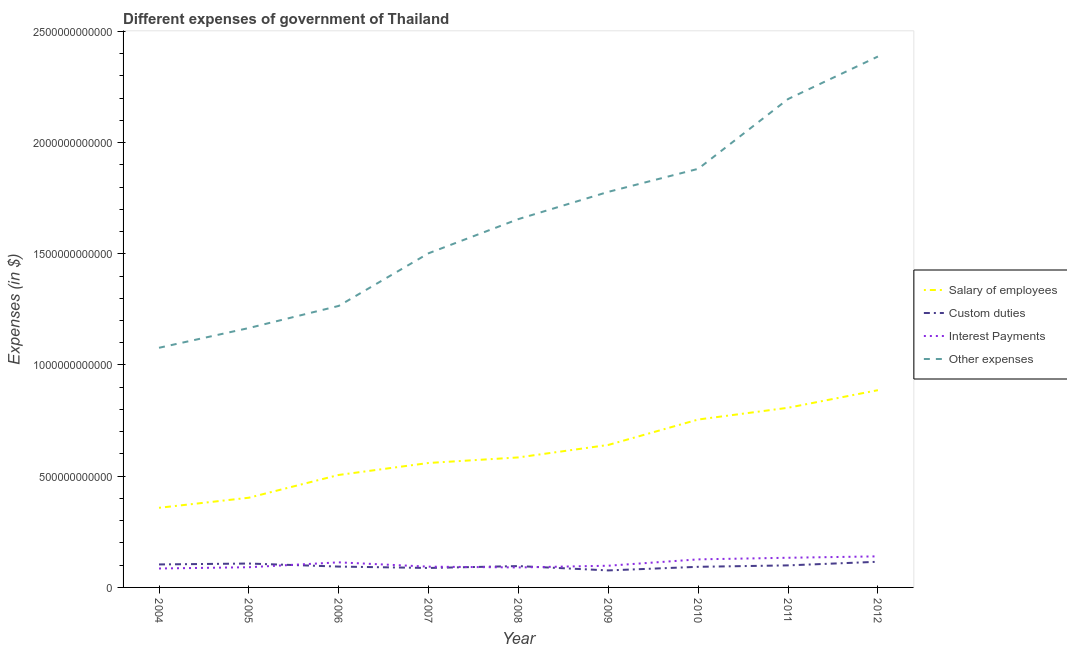How many different coloured lines are there?
Offer a very short reply. 4. Does the line corresponding to amount spent on interest payments intersect with the line corresponding to amount spent on custom duties?
Your answer should be compact. Yes. What is the amount spent on interest payments in 2009?
Offer a very short reply. 9.76e+1. Across all years, what is the maximum amount spent on interest payments?
Your answer should be compact. 1.40e+11. Across all years, what is the minimum amount spent on other expenses?
Ensure brevity in your answer.  1.08e+12. In which year was the amount spent on interest payments maximum?
Your answer should be very brief. 2012. In which year was the amount spent on other expenses minimum?
Give a very brief answer. 2004. What is the total amount spent on other expenses in the graph?
Offer a very short reply. 1.49e+13. What is the difference between the amount spent on custom duties in 2004 and that in 2007?
Give a very brief answer. 1.59e+1. What is the difference between the amount spent on custom duties in 2004 and the amount spent on interest payments in 2012?
Provide a short and direct response. -3.64e+1. What is the average amount spent on interest payments per year?
Your response must be concise. 1.08e+11. In the year 2005, what is the difference between the amount spent on salary of employees and amount spent on other expenses?
Provide a short and direct response. -7.63e+11. What is the ratio of the amount spent on salary of employees in 2010 to that in 2012?
Provide a short and direct response. 0.85. Is the amount spent on salary of employees in 2010 less than that in 2011?
Your answer should be very brief. Yes. Is the difference between the amount spent on other expenses in 2006 and 2010 greater than the difference between the amount spent on interest payments in 2006 and 2010?
Your answer should be very brief. No. What is the difference between the highest and the second highest amount spent on other expenses?
Ensure brevity in your answer.  1.91e+11. What is the difference between the highest and the lowest amount spent on salary of employees?
Ensure brevity in your answer.  5.29e+11. In how many years, is the amount spent on custom duties greater than the average amount spent on custom duties taken over all years?
Make the answer very short. 4. Is the sum of the amount spent on custom duties in 2006 and 2007 greater than the maximum amount spent on salary of employees across all years?
Provide a short and direct response. No. Is it the case that in every year, the sum of the amount spent on interest payments and amount spent on salary of employees is greater than the sum of amount spent on custom duties and amount spent on other expenses?
Provide a short and direct response. Yes. Is it the case that in every year, the sum of the amount spent on salary of employees and amount spent on custom duties is greater than the amount spent on interest payments?
Your answer should be compact. Yes. How many years are there in the graph?
Your answer should be very brief. 9. What is the difference between two consecutive major ticks on the Y-axis?
Give a very brief answer. 5.00e+11. Are the values on the major ticks of Y-axis written in scientific E-notation?
Make the answer very short. No. How many legend labels are there?
Offer a terse response. 4. What is the title of the graph?
Provide a short and direct response. Different expenses of government of Thailand. What is the label or title of the Y-axis?
Your response must be concise. Expenses (in $). What is the Expenses (in $) of Salary of employees in 2004?
Your response must be concise. 3.58e+11. What is the Expenses (in $) in Custom duties in 2004?
Provide a short and direct response. 1.03e+11. What is the Expenses (in $) of Interest Payments in 2004?
Keep it short and to the point. 8.51e+1. What is the Expenses (in $) in Other expenses in 2004?
Provide a short and direct response. 1.08e+12. What is the Expenses (in $) in Salary of employees in 2005?
Provide a succinct answer. 4.03e+11. What is the Expenses (in $) in Custom duties in 2005?
Your response must be concise. 1.07e+11. What is the Expenses (in $) in Interest Payments in 2005?
Ensure brevity in your answer.  9.08e+1. What is the Expenses (in $) of Other expenses in 2005?
Keep it short and to the point. 1.17e+12. What is the Expenses (in $) in Salary of employees in 2006?
Offer a very short reply. 5.06e+11. What is the Expenses (in $) of Custom duties in 2006?
Ensure brevity in your answer.  9.37e+1. What is the Expenses (in $) in Interest Payments in 2006?
Offer a very short reply. 1.13e+11. What is the Expenses (in $) of Other expenses in 2006?
Ensure brevity in your answer.  1.27e+12. What is the Expenses (in $) of Salary of employees in 2007?
Your answer should be compact. 5.59e+11. What is the Expenses (in $) in Custom duties in 2007?
Provide a succinct answer. 8.74e+1. What is the Expenses (in $) of Interest Payments in 2007?
Provide a succinct answer. 9.33e+1. What is the Expenses (in $) in Other expenses in 2007?
Your answer should be compact. 1.50e+12. What is the Expenses (in $) of Salary of employees in 2008?
Make the answer very short. 5.84e+11. What is the Expenses (in $) in Custom duties in 2008?
Make the answer very short. 9.60e+1. What is the Expenses (in $) of Interest Payments in 2008?
Offer a terse response. 8.98e+1. What is the Expenses (in $) in Other expenses in 2008?
Make the answer very short. 1.66e+12. What is the Expenses (in $) of Salary of employees in 2009?
Give a very brief answer. 6.41e+11. What is the Expenses (in $) in Custom duties in 2009?
Your answer should be compact. 7.65e+1. What is the Expenses (in $) in Interest Payments in 2009?
Your response must be concise. 9.76e+1. What is the Expenses (in $) of Other expenses in 2009?
Keep it short and to the point. 1.78e+12. What is the Expenses (in $) of Salary of employees in 2010?
Offer a terse response. 7.55e+11. What is the Expenses (in $) in Custom duties in 2010?
Provide a succinct answer. 9.27e+1. What is the Expenses (in $) in Interest Payments in 2010?
Provide a short and direct response. 1.26e+11. What is the Expenses (in $) of Other expenses in 2010?
Provide a short and direct response. 1.88e+12. What is the Expenses (in $) of Salary of employees in 2011?
Your answer should be compact. 8.08e+11. What is the Expenses (in $) of Custom duties in 2011?
Make the answer very short. 9.91e+1. What is the Expenses (in $) of Interest Payments in 2011?
Offer a very short reply. 1.33e+11. What is the Expenses (in $) in Other expenses in 2011?
Offer a very short reply. 2.20e+12. What is the Expenses (in $) in Salary of employees in 2012?
Your answer should be very brief. 8.87e+11. What is the Expenses (in $) in Custom duties in 2012?
Offer a terse response. 1.15e+11. What is the Expenses (in $) in Interest Payments in 2012?
Offer a terse response. 1.40e+11. What is the Expenses (in $) of Other expenses in 2012?
Offer a terse response. 2.39e+12. Across all years, what is the maximum Expenses (in $) in Salary of employees?
Offer a terse response. 8.87e+11. Across all years, what is the maximum Expenses (in $) of Custom duties?
Offer a terse response. 1.15e+11. Across all years, what is the maximum Expenses (in $) in Interest Payments?
Provide a short and direct response. 1.40e+11. Across all years, what is the maximum Expenses (in $) in Other expenses?
Offer a very short reply. 2.39e+12. Across all years, what is the minimum Expenses (in $) in Salary of employees?
Keep it short and to the point. 3.58e+11. Across all years, what is the minimum Expenses (in $) of Custom duties?
Your answer should be very brief. 7.65e+1. Across all years, what is the minimum Expenses (in $) in Interest Payments?
Keep it short and to the point. 8.51e+1. Across all years, what is the minimum Expenses (in $) in Other expenses?
Offer a very short reply. 1.08e+12. What is the total Expenses (in $) in Salary of employees in the graph?
Make the answer very short. 5.50e+12. What is the total Expenses (in $) in Custom duties in the graph?
Keep it short and to the point. 8.72e+11. What is the total Expenses (in $) in Interest Payments in the graph?
Give a very brief answer. 9.69e+11. What is the total Expenses (in $) in Other expenses in the graph?
Make the answer very short. 1.49e+13. What is the difference between the Expenses (in $) of Salary of employees in 2004 and that in 2005?
Provide a succinct answer. -4.53e+1. What is the difference between the Expenses (in $) in Custom duties in 2004 and that in 2005?
Your answer should be compact. -4.06e+09. What is the difference between the Expenses (in $) of Interest Payments in 2004 and that in 2005?
Your answer should be compact. -5.71e+09. What is the difference between the Expenses (in $) in Other expenses in 2004 and that in 2005?
Your response must be concise. -8.88e+1. What is the difference between the Expenses (in $) of Salary of employees in 2004 and that in 2006?
Provide a short and direct response. -1.48e+11. What is the difference between the Expenses (in $) in Custom duties in 2004 and that in 2006?
Ensure brevity in your answer.  9.59e+09. What is the difference between the Expenses (in $) in Interest Payments in 2004 and that in 2006?
Your response must be concise. -2.77e+1. What is the difference between the Expenses (in $) of Other expenses in 2004 and that in 2006?
Make the answer very short. -1.88e+11. What is the difference between the Expenses (in $) of Salary of employees in 2004 and that in 2007?
Give a very brief answer. -2.02e+11. What is the difference between the Expenses (in $) of Custom duties in 2004 and that in 2007?
Offer a terse response. 1.59e+1. What is the difference between the Expenses (in $) in Interest Payments in 2004 and that in 2007?
Provide a short and direct response. -8.24e+09. What is the difference between the Expenses (in $) in Other expenses in 2004 and that in 2007?
Make the answer very short. -4.25e+11. What is the difference between the Expenses (in $) of Salary of employees in 2004 and that in 2008?
Give a very brief answer. -2.27e+11. What is the difference between the Expenses (in $) of Custom duties in 2004 and that in 2008?
Give a very brief answer. 7.33e+09. What is the difference between the Expenses (in $) of Interest Payments in 2004 and that in 2008?
Keep it short and to the point. -4.69e+09. What is the difference between the Expenses (in $) of Other expenses in 2004 and that in 2008?
Your answer should be very brief. -5.79e+11. What is the difference between the Expenses (in $) of Salary of employees in 2004 and that in 2009?
Make the answer very short. -2.83e+11. What is the difference between the Expenses (in $) of Custom duties in 2004 and that in 2009?
Provide a short and direct response. 2.69e+1. What is the difference between the Expenses (in $) in Interest Payments in 2004 and that in 2009?
Give a very brief answer. -1.24e+1. What is the difference between the Expenses (in $) in Other expenses in 2004 and that in 2009?
Offer a terse response. -7.01e+11. What is the difference between the Expenses (in $) in Salary of employees in 2004 and that in 2010?
Offer a very short reply. -3.97e+11. What is the difference between the Expenses (in $) of Custom duties in 2004 and that in 2010?
Provide a short and direct response. 1.07e+1. What is the difference between the Expenses (in $) of Interest Payments in 2004 and that in 2010?
Your answer should be compact. -4.10e+1. What is the difference between the Expenses (in $) of Other expenses in 2004 and that in 2010?
Make the answer very short. -8.05e+11. What is the difference between the Expenses (in $) of Salary of employees in 2004 and that in 2011?
Provide a succinct answer. -4.50e+11. What is the difference between the Expenses (in $) of Custom duties in 2004 and that in 2011?
Ensure brevity in your answer.  4.22e+09. What is the difference between the Expenses (in $) in Interest Payments in 2004 and that in 2011?
Keep it short and to the point. -4.83e+1. What is the difference between the Expenses (in $) of Other expenses in 2004 and that in 2011?
Keep it short and to the point. -1.12e+12. What is the difference between the Expenses (in $) in Salary of employees in 2004 and that in 2012?
Provide a succinct answer. -5.29e+11. What is the difference between the Expenses (in $) in Custom duties in 2004 and that in 2012?
Offer a terse response. -1.21e+1. What is the difference between the Expenses (in $) in Interest Payments in 2004 and that in 2012?
Your response must be concise. -5.46e+1. What is the difference between the Expenses (in $) in Other expenses in 2004 and that in 2012?
Your answer should be very brief. -1.31e+12. What is the difference between the Expenses (in $) in Salary of employees in 2005 and that in 2006?
Offer a very short reply. -1.02e+11. What is the difference between the Expenses (in $) of Custom duties in 2005 and that in 2006?
Your response must be concise. 1.36e+1. What is the difference between the Expenses (in $) in Interest Payments in 2005 and that in 2006?
Your response must be concise. -2.19e+1. What is the difference between the Expenses (in $) in Other expenses in 2005 and that in 2006?
Your response must be concise. -9.94e+1. What is the difference between the Expenses (in $) in Salary of employees in 2005 and that in 2007?
Make the answer very short. -1.56e+11. What is the difference between the Expenses (in $) of Custom duties in 2005 and that in 2007?
Your answer should be very brief. 2.00e+1. What is the difference between the Expenses (in $) in Interest Payments in 2005 and that in 2007?
Keep it short and to the point. -2.53e+09. What is the difference between the Expenses (in $) in Other expenses in 2005 and that in 2007?
Offer a terse response. -3.36e+11. What is the difference between the Expenses (in $) of Salary of employees in 2005 and that in 2008?
Give a very brief answer. -1.81e+11. What is the difference between the Expenses (in $) in Custom duties in 2005 and that in 2008?
Make the answer very short. 1.14e+1. What is the difference between the Expenses (in $) in Interest Payments in 2005 and that in 2008?
Offer a very short reply. 1.02e+09. What is the difference between the Expenses (in $) in Other expenses in 2005 and that in 2008?
Ensure brevity in your answer.  -4.90e+11. What is the difference between the Expenses (in $) of Salary of employees in 2005 and that in 2009?
Make the answer very short. -2.37e+11. What is the difference between the Expenses (in $) of Custom duties in 2005 and that in 2009?
Provide a succinct answer. 3.09e+1. What is the difference between the Expenses (in $) of Interest Payments in 2005 and that in 2009?
Offer a terse response. -6.73e+09. What is the difference between the Expenses (in $) in Other expenses in 2005 and that in 2009?
Your response must be concise. -6.12e+11. What is the difference between the Expenses (in $) in Salary of employees in 2005 and that in 2010?
Your answer should be very brief. -3.52e+11. What is the difference between the Expenses (in $) in Custom duties in 2005 and that in 2010?
Ensure brevity in your answer.  1.47e+1. What is the difference between the Expenses (in $) in Interest Payments in 2005 and that in 2010?
Provide a succinct answer. -3.53e+1. What is the difference between the Expenses (in $) in Other expenses in 2005 and that in 2010?
Make the answer very short. -7.16e+11. What is the difference between the Expenses (in $) in Salary of employees in 2005 and that in 2011?
Your answer should be compact. -4.04e+11. What is the difference between the Expenses (in $) of Custom duties in 2005 and that in 2011?
Give a very brief answer. 8.28e+09. What is the difference between the Expenses (in $) in Interest Payments in 2005 and that in 2011?
Your answer should be very brief. -4.26e+1. What is the difference between the Expenses (in $) in Other expenses in 2005 and that in 2011?
Give a very brief answer. -1.03e+12. What is the difference between the Expenses (in $) of Salary of employees in 2005 and that in 2012?
Your answer should be very brief. -4.83e+11. What is the difference between the Expenses (in $) of Custom duties in 2005 and that in 2012?
Give a very brief answer. -8.00e+09. What is the difference between the Expenses (in $) of Interest Payments in 2005 and that in 2012?
Your response must be concise. -4.89e+1. What is the difference between the Expenses (in $) in Other expenses in 2005 and that in 2012?
Your answer should be compact. -1.22e+12. What is the difference between the Expenses (in $) in Salary of employees in 2006 and that in 2007?
Your response must be concise. -5.38e+1. What is the difference between the Expenses (in $) of Custom duties in 2006 and that in 2007?
Keep it short and to the point. 6.31e+09. What is the difference between the Expenses (in $) in Interest Payments in 2006 and that in 2007?
Provide a short and direct response. 1.94e+1. What is the difference between the Expenses (in $) in Other expenses in 2006 and that in 2007?
Your response must be concise. -2.37e+11. What is the difference between the Expenses (in $) in Salary of employees in 2006 and that in 2008?
Offer a very short reply. -7.89e+1. What is the difference between the Expenses (in $) of Custom duties in 2006 and that in 2008?
Offer a very short reply. -2.25e+09. What is the difference between the Expenses (in $) in Interest Payments in 2006 and that in 2008?
Give a very brief answer. 2.30e+1. What is the difference between the Expenses (in $) in Other expenses in 2006 and that in 2008?
Provide a succinct answer. -3.90e+11. What is the difference between the Expenses (in $) in Salary of employees in 2006 and that in 2009?
Provide a short and direct response. -1.35e+11. What is the difference between the Expenses (in $) of Custom duties in 2006 and that in 2009?
Keep it short and to the point. 1.73e+1. What is the difference between the Expenses (in $) of Interest Payments in 2006 and that in 2009?
Ensure brevity in your answer.  1.52e+1. What is the difference between the Expenses (in $) in Other expenses in 2006 and that in 2009?
Ensure brevity in your answer.  -5.13e+11. What is the difference between the Expenses (in $) in Salary of employees in 2006 and that in 2010?
Ensure brevity in your answer.  -2.49e+11. What is the difference between the Expenses (in $) in Custom duties in 2006 and that in 2010?
Ensure brevity in your answer.  1.07e+09. What is the difference between the Expenses (in $) of Interest Payments in 2006 and that in 2010?
Offer a terse response. -1.34e+1. What is the difference between the Expenses (in $) of Other expenses in 2006 and that in 2010?
Provide a succinct answer. -6.16e+11. What is the difference between the Expenses (in $) of Salary of employees in 2006 and that in 2011?
Your answer should be compact. -3.02e+11. What is the difference between the Expenses (in $) in Custom duties in 2006 and that in 2011?
Give a very brief answer. -5.36e+09. What is the difference between the Expenses (in $) of Interest Payments in 2006 and that in 2011?
Provide a short and direct response. -2.06e+1. What is the difference between the Expenses (in $) in Other expenses in 2006 and that in 2011?
Give a very brief answer. -9.30e+11. What is the difference between the Expenses (in $) of Salary of employees in 2006 and that in 2012?
Offer a very short reply. -3.81e+11. What is the difference between the Expenses (in $) in Custom duties in 2006 and that in 2012?
Your answer should be compact. -2.16e+1. What is the difference between the Expenses (in $) in Interest Payments in 2006 and that in 2012?
Ensure brevity in your answer.  -2.70e+1. What is the difference between the Expenses (in $) of Other expenses in 2006 and that in 2012?
Provide a succinct answer. -1.12e+12. What is the difference between the Expenses (in $) in Salary of employees in 2007 and that in 2008?
Offer a terse response. -2.50e+1. What is the difference between the Expenses (in $) in Custom duties in 2007 and that in 2008?
Provide a succinct answer. -8.56e+09. What is the difference between the Expenses (in $) in Interest Payments in 2007 and that in 2008?
Your answer should be very brief. 3.55e+09. What is the difference between the Expenses (in $) of Other expenses in 2007 and that in 2008?
Keep it short and to the point. -1.54e+11. What is the difference between the Expenses (in $) in Salary of employees in 2007 and that in 2009?
Provide a succinct answer. -8.11e+1. What is the difference between the Expenses (in $) of Custom duties in 2007 and that in 2009?
Offer a very short reply. 1.10e+1. What is the difference between the Expenses (in $) in Interest Payments in 2007 and that in 2009?
Give a very brief answer. -4.21e+09. What is the difference between the Expenses (in $) in Other expenses in 2007 and that in 2009?
Keep it short and to the point. -2.76e+11. What is the difference between the Expenses (in $) in Salary of employees in 2007 and that in 2010?
Offer a terse response. -1.95e+11. What is the difference between the Expenses (in $) of Custom duties in 2007 and that in 2010?
Your response must be concise. -5.23e+09. What is the difference between the Expenses (in $) in Interest Payments in 2007 and that in 2010?
Offer a very short reply. -3.28e+1. What is the difference between the Expenses (in $) in Other expenses in 2007 and that in 2010?
Offer a very short reply. -3.80e+11. What is the difference between the Expenses (in $) in Salary of employees in 2007 and that in 2011?
Your answer should be very brief. -2.48e+11. What is the difference between the Expenses (in $) in Custom duties in 2007 and that in 2011?
Your response must be concise. -1.17e+1. What is the difference between the Expenses (in $) in Interest Payments in 2007 and that in 2011?
Your answer should be compact. -4.00e+1. What is the difference between the Expenses (in $) of Other expenses in 2007 and that in 2011?
Your response must be concise. -6.93e+11. What is the difference between the Expenses (in $) of Salary of employees in 2007 and that in 2012?
Provide a succinct answer. -3.27e+11. What is the difference between the Expenses (in $) of Custom duties in 2007 and that in 2012?
Keep it short and to the point. -2.79e+1. What is the difference between the Expenses (in $) of Interest Payments in 2007 and that in 2012?
Give a very brief answer. -4.64e+1. What is the difference between the Expenses (in $) in Other expenses in 2007 and that in 2012?
Your answer should be compact. -8.84e+11. What is the difference between the Expenses (in $) of Salary of employees in 2008 and that in 2009?
Offer a terse response. -5.61e+1. What is the difference between the Expenses (in $) in Custom duties in 2008 and that in 2009?
Offer a very short reply. 1.95e+1. What is the difference between the Expenses (in $) in Interest Payments in 2008 and that in 2009?
Keep it short and to the point. -7.75e+09. What is the difference between the Expenses (in $) in Other expenses in 2008 and that in 2009?
Your answer should be very brief. -1.22e+11. What is the difference between the Expenses (in $) in Salary of employees in 2008 and that in 2010?
Give a very brief answer. -1.70e+11. What is the difference between the Expenses (in $) of Custom duties in 2008 and that in 2010?
Give a very brief answer. 3.32e+09. What is the difference between the Expenses (in $) in Interest Payments in 2008 and that in 2010?
Offer a very short reply. -3.64e+1. What is the difference between the Expenses (in $) in Other expenses in 2008 and that in 2010?
Provide a short and direct response. -2.26e+11. What is the difference between the Expenses (in $) of Salary of employees in 2008 and that in 2011?
Provide a succinct answer. -2.23e+11. What is the difference between the Expenses (in $) of Custom duties in 2008 and that in 2011?
Ensure brevity in your answer.  -3.11e+09. What is the difference between the Expenses (in $) of Interest Payments in 2008 and that in 2011?
Offer a terse response. -4.36e+1. What is the difference between the Expenses (in $) of Other expenses in 2008 and that in 2011?
Provide a short and direct response. -5.40e+11. What is the difference between the Expenses (in $) of Salary of employees in 2008 and that in 2012?
Your answer should be compact. -3.02e+11. What is the difference between the Expenses (in $) of Custom duties in 2008 and that in 2012?
Provide a short and direct response. -1.94e+1. What is the difference between the Expenses (in $) of Interest Payments in 2008 and that in 2012?
Ensure brevity in your answer.  -4.99e+1. What is the difference between the Expenses (in $) in Other expenses in 2008 and that in 2012?
Ensure brevity in your answer.  -7.31e+11. What is the difference between the Expenses (in $) in Salary of employees in 2009 and that in 2010?
Make the answer very short. -1.14e+11. What is the difference between the Expenses (in $) in Custom duties in 2009 and that in 2010?
Your response must be concise. -1.62e+1. What is the difference between the Expenses (in $) in Interest Payments in 2009 and that in 2010?
Your answer should be compact. -2.86e+1. What is the difference between the Expenses (in $) of Other expenses in 2009 and that in 2010?
Ensure brevity in your answer.  -1.04e+11. What is the difference between the Expenses (in $) of Salary of employees in 2009 and that in 2011?
Offer a very short reply. -1.67e+11. What is the difference between the Expenses (in $) of Custom duties in 2009 and that in 2011?
Ensure brevity in your answer.  -2.26e+1. What is the difference between the Expenses (in $) of Interest Payments in 2009 and that in 2011?
Keep it short and to the point. -3.58e+1. What is the difference between the Expenses (in $) in Other expenses in 2009 and that in 2011?
Offer a very short reply. -4.17e+11. What is the difference between the Expenses (in $) in Salary of employees in 2009 and that in 2012?
Ensure brevity in your answer.  -2.46e+11. What is the difference between the Expenses (in $) in Custom duties in 2009 and that in 2012?
Provide a succinct answer. -3.89e+1. What is the difference between the Expenses (in $) of Interest Payments in 2009 and that in 2012?
Offer a terse response. -4.22e+1. What is the difference between the Expenses (in $) of Other expenses in 2009 and that in 2012?
Provide a succinct answer. -6.08e+11. What is the difference between the Expenses (in $) of Salary of employees in 2010 and that in 2011?
Your answer should be very brief. -5.29e+1. What is the difference between the Expenses (in $) of Custom duties in 2010 and that in 2011?
Provide a succinct answer. -6.44e+09. What is the difference between the Expenses (in $) of Interest Payments in 2010 and that in 2011?
Your answer should be very brief. -7.23e+09. What is the difference between the Expenses (in $) in Other expenses in 2010 and that in 2011?
Provide a succinct answer. -3.14e+11. What is the difference between the Expenses (in $) in Salary of employees in 2010 and that in 2012?
Your answer should be compact. -1.32e+11. What is the difference between the Expenses (in $) of Custom duties in 2010 and that in 2012?
Your response must be concise. -2.27e+1. What is the difference between the Expenses (in $) of Interest Payments in 2010 and that in 2012?
Your response must be concise. -1.36e+1. What is the difference between the Expenses (in $) in Other expenses in 2010 and that in 2012?
Your answer should be very brief. -5.05e+11. What is the difference between the Expenses (in $) of Salary of employees in 2011 and that in 2012?
Offer a terse response. -7.91e+1. What is the difference between the Expenses (in $) of Custom duties in 2011 and that in 2012?
Your answer should be compact. -1.63e+1. What is the difference between the Expenses (in $) in Interest Payments in 2011 and that in 2012?
Keep it short and to the point. -6.33e+09. What is the difference between the Expenses (in $) in Other expenses in 2011 and that in 2012?
Provide a short and direct response. -1.91e+11. What is the difference between the Expenses (in $) in Salary of employees in 2004 and the Expenses (in $) in Custom duties in 2005?
Keep it short and to the point. 2.51e+11. What is the difference between the Expenses (in $) of Salary of employees in 2004 and the Expenses (in $) of Interest Payments in 2005?
Your response must be concise. 2.67e+11. What is the difference between the Expenses (in $) of Salary of employees in 2004 and the Expenses (in $) of Other expenses in 2005?
Your answer should be very brief. -8.08e+11. What is the difference between the Expenses (in $) in Custom duties in 2004 and the Expenses (in $) in Interest Payments in 2005?
Offer a terse response. 1.25e+1. What is the difference between the Expenses (in $) in Custom duties in 2004 and the Expenses (in $) in Other expenses in 2005?
Offer a very short reply. -1.06e+12. What is the difference between the Expenses (in $) in Interest Payments in 2004 and the Expenses (in $) in Other expenses in 2005?
Make the answer very short. -1.08e+12. What is the difference between the Expenses (in $) of Salary of employees in 2004 and the Expenses (in $) of Custom duties in 2006?
Your response must be concise. 2.64e+11. What is the difference between the Expenses (in $) of Salary of employees in 2004 and the Expenses (in $) of Interest Payments in 2006?
Give a very brief answer. 2.45e+11. What is the difference between the Expenses (in $) of Salary of employees in 2004 and the Expenses (in $) of Other expenses in 2006?
Offer a very short reply. -9.08e+11. What is the difference between the Expenses (in $) of Custom duties in 2004 and the Expenses (in $) of Interest Payments in 2006?
Keep it short and to the point. -9.43e+09. What is the difference between the Expenses (in $) in Custom duties in 2004 and the Expenses (in $) in Other expenses in 2006?
Provide a short and direct response. -1.16e+12. What is the difference between the Expenses (in $) of Interest Payments in 2004 and the Expenses (in $) of Other expenses in 2006?
Offer a terse response. -1.18e+12. What is the difference between the Expenses (in $) in Salary of employees in 2004 and the Expenses (in $) in Custom duties in 2007?
Ensure brevity in your answer.  2.70e+11. What is the difference between the Expenses (in $) in Salary of employees in 2004 and the Expenses (in $) in Interest Payments in 2007?
Give a very brief answer. 2.65e+11. What is the difference between the Expenses (in $) in Salary of employees in 2004 and the Expenses (in $) in Other expenses in 2007?
Your answer should be very brief. -1.14e+12. What is the difference between the Expenses (in $) of Custom duties in 2004 and the Expenses (in $) of Interest Payments in 2007?
Keep it short and to the point. 9.99e+09. What is the difference between the Expenses (in $) in Custom duties in 2004 and the Expenses (in $) in Other expenses in 2007?
Ensure brevity in your answer.  -1.40e+12. What is the difference between the Expenses (in $) of Interest Payments in 2004 and the Expenses (in $) of Other expenses in 2007?
Your answer should be compact. -1.42e+12. What is the difference between the Expenses (in $) of Salary of employees in 2004 and the Expenses (in $) of Custom duties in 2008?
Give a very brief answer. 2.62e+11. What is the difference between the Expenses (in $) in Salary of employees in 2004 and the Expenses (in $) in Interest Payments in 2008?
Give a very brief answer. 2.68e+11. What is the difference between the Expenses (in $) of Salary of employees in 2004 and the Expenses (in $) of Other expenses in 2008?
Provide a succinct answer. -1.30e+12. What is the difference between the Expenses (in $) in Custom duties in 2004 and the Expenses (in $) in Interest Payments in 2008?
Your answer should be very brief. 1.35e+1. What is the difference between the Expenses (in $) in Custom duties in 2004 and the Expenses (in $) in Other expenses in 2008?
Ensure brevity in your answer.  -1.55e+12. What is the difference between the Expenses (in $) of Interest Payments in 2004 and the Expenses (in $) of Other expenses in 2008?
Ensure brevity in your answer.  -1.57e+12. What is the difference between the Expenses (in $) of Salary of employees in 2004 and the Expenses (in $) of Custom duties in 2009?
Provide a short and direct response. 2.81e+11. What is the difference between the Expenses (in $) in Salary of employees in 2004 and the Expenses (in $) in Interest Payments in 2009?
Provide a short and direct response. 2.60e+11. What is the difference between the Expenses (in $) of Salary of employees in 2004 and the Expenses (in $) of Other expenses in 2009?
Make the answer very short. -1.42e+12. What is the difference between the Expenses (in $) in Custom duties in 2004 and the Expenses (in $) in Interest Payments in 2009?
Your answer should be very brief. 5.78e+09. What is the difference between the Expenses (in $) of Custom duties in 2004 and the Expenses (in $) of Other expenses in 2009?
Ensure brevity in your answer.  -1.68e+12. What is the difference between the Expenses (in $) in Interest Payments in 2004 and the Expenses (in $) in Other expenses in 2009?
Provide a succinct answer. -1.69e+12. What is the difference between the Expenses (in $) in Salary of employees in 2004 and the Expenses (in $) in Custom duties in 2010?
Provide a succinct answer. 2.65e+11. What is the difference between the Expenses (in $) of Salary of employees in 2004 and the Expenses (in $) of Interest Payments in 2010?
Give a very brief answer. 2.32e+11. What is the difference between the Expenses (in $) in Salary of employees in 2004 and the Expenses (in $) in Other expenses in 2010?
Provide a short and direct response. -1.52e+12. What is the difference between the Expenses (in $) in Custom duties in 2004 and the Expenses (in $) in Interest Payments in 2010?
Provide a short and direct response. -2.28e+1. What is the difference between the Expenses (in $) of Custom duties in 2004 and the Expenses (in $) of Other expenses in 2010?
Ensure brevity in your answer.  -1.78e+12. What is the difference between the Expenses (in $) in Interest Payments in 2004 and the Expenses (in $) in Other expenses in 2010?
Ensure brevity in your answer.  -1.80e+12. What is the difference between the Expenses (in $) in Salary of employees in 2004 and the Expenses (in $) in Custom duties in 2011?
Your answer should be compact. 2.59e+11. What is the difference between the Expenses (in $) of Salary of employees in 2004 and the Expenses (in $) of Interest Payments in 2011?
Make the answer very short. 2.25e+11. What is the difference between the Expenses (in $) in Salary of employees in 2004 and the Expenses (in $) in Other expenses in 2011?
Your answer should be compact. -1.84e+12. What is the difference between the Expenses (in $) in Custom duties in 2004 and the Expenses (in $) in Interest Payments in 2011?
Make the answer very short. -3.01e+1. What is the difference between the Expenses (in $) of Custom duties in 2004 and the Expenses (in $) of Other expenses in 2011?
Keep it short and to the point. -2.09e+12. What is the difference between the Expenses (in $) of Interest Payments in 2004 and the Expenses (in $) of Other expenses in 2011?
Provide a succinct answer. -2.11e+12. What is the difference between the Expenses (in $) of Salary of employees in 2004 and the Expenses (in $) of Custom duties in 2012?
Your response must be concise. 2.43e+11. What is the difference between the Expenses (in $) of Salary of employees in 2004 and the Expenses (in $) of Interest Payments in 2012?
Keep it short and to the point. 2.18e+11. What is the difference between the Expenses (in $) of Salary of employees in 2004 and the Expenses (in $) of Other expenses in 2012?
Your answer should be compact. -2.03e+12. What is the difference between the Expenses (in $) in Custom duties in 2004 and the Expenses (in $) in Interest Payments in 2012?
Your answer should be compact. -3.64e+1. What is the difference between the Expenses (in $) in Custom duties in 2004 and the Expenses (in $) in Other expenses in 2012?
Make the answer very short. -2.28e+12. What is the difference between the Expenses (in $) in Interest Payments in 2004 and the Expenses (in $) in Other expenses in 2012?
Provide a short and direct response. -2.30e+12. What is the difference between the Expenses (in $) of Salary of employees in 2005 and the Expenses (in $) of Custom duties in 2006?
Your answer should be compact. 3.10e+11. What is the difference between the Expenses (in $) of Salary of employees in 2005 and the Expenses (in $) of Interest Payments in 2006?
Ensure brevity in your answer.  2.91e+11. What is the difference between the Expenses (in $) of Salary of employees in 2005 and the Expenses (in $) of Other expenses in 2006?
Provide a succinct answer. -8.62e+11. What is the difference between the Expenses (in $) of Custom duties in 2005 and the Expenses (in $) of Interest Payments in 2006?
Offer a very short reply. -5.37e+09. What is the difference between the Expenses (in $) of Custom duties in 2005 and the Expenses (in $) of Other expenses in 2006?
Give a very brief answer. -1.16e+12. What is the difference between the Expenses (in $) in Interest Payments in 2005 and the Expenses (in $) in Other expenses in 2006?
Your answer should be very brief. -1.17e+12. What is the difference between the Expenses (in $) in Salary of employees in 2005 and the Expenses (in $) in Custom duties in 2007?
Give a very brief answer. 3.16e+11. What is the difference between the Expenses (in $) of Salary of employees in 2005 and the Expenses (in $) of Interest Payments in 2007?
Give a very brief answer. 3.10e+11. What is the difference between the Expenses (in $) of Salary of employees in 2005 and the Expenses (in $) of Other expenses in 2007?
Provide a succinct answer. -1.10e+12. What is the difference between the Expenses (in $) in Custom duties in 2005 and the Expenses (in $) in Interest Payments in 2007?
Provide a short and direct response. 1.40e+1. What is the difference between the Expenses (in $) in Custom duties in 2005 and the Expenses (in $) in Other expenses in 2007?
Provide a succinct answer. -1.39e+12. What is the difference between the Expenses (in $) of Interest Payments in 2005 and the Expenses (in $) of Other expenses in 2007?
Make the answer very short. -1.41e+12. What is the difference between the Expenses (in $) in Salary of employees in 2005 and the Expenses (in $) in Custom duties in 2008?
Your response must be concise. 3.07e+11. What is the difference between the Expenses (in $) in Salary of employees in 2005 and the Expenses (in $) in Interest Payments in 2008?
Your answer should be very brief. 3.13e+11. What is the difference between the Expenses (in $) in Salary of employees in 2005 and the Expenses (in $) in Other expenses in 2008?
Ensure brevity in your answer.  -1.25e+12. What is the difference between the Expenses (in $) of Custom duties in 2005 and the Expenses (in $) of Interest Payments in 2008?
Offer a terse response. 1.76e+1. What is the difference between the Expenses (in $) in Custom duties in 2005 and the Expenses (in $) in Other expenses in 2008?
Provide a short and direct response. -1.55e+12. What is the difference between the Expenses (in $) in Interest Payments in 2005 and the Expenses (in $) in Other expenses in 2008?
Your response must be concise. -1.57e+12. What is the difference between the Expenses (in $) of Salary of employees in 2005 and the Expenses (in $) of Custom duties in 2009?
Offer a terse response. 3.27e+11. What is the difference between the Expenses (in $) of Salary of employees in 2005 and the Expenses (in $) of Interest Payments in 2009?
Offer a terse response. 3.06e+11. What is the difference between the Expenses (in $) of Salary of employees in 2005 and the Expenses (in $) of Other expenses in 2009?
Make the answer very short. -1.38e+12. What is the difference between the Expenses (in $) in Custom duties in 2005 and the Expenses (in $) in Interest Payments in 2009?
Give a very brief answer. 9.84e+09. What is the difference between the Expenses (in $) of Custom duties in 2005 and the Expenses (in $) of Other expenses in 2009?
Keep it short and to the point. -1.67e+12. What is the difference between the Expenses (in $) in Interest Payments in 2005 and the Expenses (in $) in Other expenses in 2009?
Give a very brief answer. -1.69e+12. What is the difference between the Expenses (in $) in Salary of employees in 2005 and the Expenses (in $) in Custom duties in 2010?
Offer a terse response. 3.11e+11. What is the difference between the Expenses (in $) in Salary of employees in 2005 and the Expenses (in $) in Interest Payments in 2010?
Make the answer very short. 2.77e+11. What is the difference between the Expenses (in $) in Salary of employees in 2005 and the Expenses (in $) in Other expenses in 2010?
Your answer should be compact. -1.48e+12. What is the difference between the Expenses (in $) of Custom duties in 2005 and the Expenses (in $) of Interest Payments in 2010?
Offer a very short reply. -1.88e+1. What is the difference between the Expenses (in $) of Custom duties in 2005 and the Expenses (in $) of Other expenses in 2010?
Provide a succinct answer. -1.77e+12. What is the difference between the Expenses (in $) of Interest Payments in 2005 and the Expenses (in $) of Other expenses in 2010?
Ensure brevity in your answer.  -1.79e+12. What is the difference between the Expenses (in $) in Salary of employees in 2005 and the Expenses (in $) in Custom duties in 2011?
Your response must be concise. 3.04e+11. What is the difference between the Expenses (in $) of Salary of employees in 2005 and the Expenses (in $) of Interest Payments in 2011?
Give a very brief answer. 2.70e+11. What is the difference between the Expenses (in $) of Salary of employees in 2005 and the Expenses (in $) of Other expenses in 2011?
Provide a short and direct response. -1.79e+12. What is the difference between the Expenses (in $) in Custom duties in 2005 and the Expenses (in $) in Interest Payments in 2011?
Give a very brief answer. -2.60e+1. What is the difference between the Expenses (in $) in Custom duties in 2005 and the Expenses (in $) in Other expenses in 2011?
Offer a very short reply. -2.09e+12. What is the difference between the Expenses (in $) of Interest Payments in 2005 and the Expenses (in $) of Other expenses in 2011?
Offer a very short reply. -2.10e+12. What is the difference between the Expenses (in $) in Salary of employees in 2005 and the Expenses (in $) in Custom duties in 2012?
Offer a very short reply. 2.88e+11. What is the difference between the Expenses (in $) of Salary of employees in 2005 and the Expenses (in $) of Interest Payments in 2012?
Provide a short and direct response. 2.64e+11. What is the difference between the Expenses (in $) of Salary of employees in 2005 and the Expenses (in $) of Other expenses in 2012?
Provide a short and direct response. -1.98e+12. What is the difference between the Expenses (in $) in Custom duties in 2005 and the Expenses (in $) in Interest Payments in 2012?
Keep it short and to the point. -3.23e+1. What is the difference between the Expenses (in $) in Custom duties in 2005 and the Expenses (in $) in Other expenses in 2012?
Give a very brief answer. -2.28e+12. What is the difference between the Expenses (in $) in Interest Payments in 2005 and the Expenses (in $) in Other expenses in 2012?
Your answer should be very brief. -2.30e+12. What is the difference between the Expenses (in $) of Salary of employees in 2006 and the Expenses (in $) of Custom duties in 2007?
Make the answer very short. 4.18e+11. What is the difference between the Expenses (in $) in Salary of employees in 2006 and the Expenses (in $) in Interest Payments in 2007?
Offer a terse response. 4.12e+11. What is the difference between the Expenses (in $) of Salary of employees in 2006 and the Expenses (in $) of Other expenses in 2007?
Provide a short and direct response. -9.97e+11. What is the difference between the Expenses (in $) in Custom duties in 2006 and the Expenses (in $) in Interest Payments in 2007?
Keep it short and to the point. 4.01e+08. What is the difference between the Expenses (in $) of Custom duties in 2006 and the Expenses (in $) of Other expenses in 2007?
Provide a succinct answer. -1.41e+12. What is the difference between the Expenses (in $) in Interest Payments in 2006 and the Expenses (in $) in Other expenses in 2007?
Provide a succinct answer. -1.39e+12. What is the difference between the Expenses (in $) in Salary of employees in 2006 and the Expenses (in $) in Custom duties in 2008?
Offer a terse response. 4.10e+11. What is the difference between the Expenses (in $) in Salary of employees in 2006 and the Expenses (in $) in Interest Payments in 2008?
Provide a succinct answer. 4.16e+11. What is the difference between the Expenses (in $) of Salary of employees in 2006 and the Expenses (in $) of Other expenses in 2008?
Keep it short and to the point. -1.15e+12. What is the difference between the Expenses (in $) in Custom duties in 2006 and the Expenses (in $) in Interest Payments in 2008?
Keep it short and to the point. 3.95e+09. What is the difference between the Expenses (in $) of Custom duties in 2006 and the Expenses (in $) of Other expenses in 2008?
Your answer should be very brief. -1.56e+12. What is the difference between the Expenses (in $) of Interest Payments in 2006 and the Expenses (in $) of Other expenses in 2008?
Provide a succinct answer. -1.54e+12. What is the difference between the Expenses (in $) of Salary of employees in 2006 and the Expenses (in $) of Custom duties in 2009?
Ensure brevity in your answer.  4.29e+11. What is the difference between the Expenses (in $) in Salary of employees in 2006 and the Expenses (in $) in Interest Payments in 2009?
Your answer should be very brief. 4.08e+11. What is the difference between the Expenses (in $) in Salary of employees in 2006 and the Expenses (in $) in Other expenses in 2009?
Provide a succinct answer. -1.27e+12. What is the difference between the Expenses (in $) of Custom duties in 2006 and the Expenses (in $) of Interest Payments in 2009?
Make the answer very short. -3.81e+09. What is the difference between the Expenses (in $) of Custom duties in 2006 and the Expenses (in $) of Other expenses in 2009?
Your response must be concise. -1.68e+12. What is the difference between the Expenses (in $) of Interest Payments in 2006 and the Expenses (in $) of Other expenses in 2009?
Offer a terse response. -1.67e+12. What is the difference between the Expenses (in $) in Salary of employees in 2006 and the Expenses (in $) in Custom duties in 2010?
Keep it short and to the point. 4.13e+11. What is the difference between the Expenses (in $) of Salary of employees in 2006 and the Expenses (in $) of Interest Payments in 2010?
Give a very brief answer. 3.79e+11. What is the difference between the Expenses (in $) of Salary of employees in 2006 and the Expenses (in $) of Other expenses in 2010?
Your answer should be compact. -1.38e+12. What is the difference between the Expenses (in $) in Custom duties in 2006 and the Expenses (in $) in Interest Payments in 2010?
Make the answer very short. -3.24e+1. What is the difference between the Expenses (in $) in Custom duties in 2006 and the Expenses (in $) in Other expenses in 2010?
Provide a short and direct response. -1.79e+12. What is the difference between the Expenses (in $) in Interest Payments in 2006 and the Expenses (in $) in Other expenses in 2010?
Your response must be concise. -1.77e+12. What is the difference between the Expenses (in $) in Salary of employees in 2006 and the Expenses (in $) in Custom duties in 2011?
Provide a short and direct response. 4.07e+11. What is the difference between the Expenses (in $) in Salary of employees in 2006 and the Expenses (in $) in Interest Payments in 2011?
Your response must be concise. 3.72e+11. What is the difference between the Expenses (in $) of Salary of employees in 2006 and the Expenses (in $) of Other expenses in 2011?
Provide a succinct answer. -1.69e+12. What is the difference between the Expenses (in $) in Custom duties in 2006 and the Expenses (in $) in Interest Payments in 2011?
Your answer should be compact. -3.96e+1. What is the difference between the Expenses (in $) in Custom duties in 2006 and the Expenses (in $) in Other expenses in 2011?
Offer a very short reply. -2.10e+12. What is the difference between the Expenses (in $) of Interest Payments in 2006 and the Expenses (in $) of Other expenses in 2011?
Your answer should be very brief. -2.08e+12. What is the difference between the Expenses (in $) in Salary of employees in 2006 and the Expenses (in $) in Custom duties in 2012?
Provide a succinct answer. 3.90e+11. What is the difference between the Expenses (in $) in Salary of employees in 2006 and the Expenses (in $) in Interest Payments in 2012?
Offer a very short reply. 3.66e+11. What is the difference between the Expenses (in $) in Salary of employees in 2006 and the Expenses (in $) in Other expenses in 2012?
Provide a short and direct response. -1.88e+12. What is the difference between the Expenses (in $) of Custom duties in 2006 and the Expenses (in $) of Interest Payments in 2012?
Offer a terse response. -4.60e+1. What is the difference between the Expenses (in $) of Custom duties in 2006 and the Expenses (in $) of Other expenses in 2012?
Make the answer very short. -2.29e+12. What is the difference between the Expenses (in $) of Interest Payments in 2006 and the Expenses (in $) of Other expenses in 2012?
Give a very brief answer. -2.27e+12. What is the difference between the Expenses (in $) in Salary of employees in 2007 and the Expenses (in $) in Custom duties in 2008?
Provide a succinct answer. 4.63e+11. What is the difference between the Expenses (in $) in Salary of employees in 2007 and the Expenses (in $) in Interest Payments in 2008?
Offer a terse response. 4.70e+11. What is the difference between the Expenses (in $) in Salary of employees in 2007 and the Expenses (in $) in Other expenses in 2008?
Make the answer very short. -1.10e+12. What is the difference between the Expenses (in $) in Custom duties in 2007 and the Expenses (in $) in Interest Payments in 2008?
Provide a succinct answer. -2.36e+09. What is the difference between the Expenses (in $) in Custom duties in 2007 and the Expenses (in $) in Other expenses in 2008?
Your answer should be compact. -1.57e+12. What is the difference between the Expenses (in $) in Interest Payments in 2007 and the Expenses (in $) in Other expenses in 2008?
Your answer should be compact. -1.56e+12. What is the difference between the Expenses (in $) of Salary of employees in 2007 and the Expenses (in $) of Custom duties in 2009?
Provide a succinct answer. 4.83e+11. What is the difference between the Expenses (in $) of Salary of employees in 2007 and the Expenses (in $) of Interest Payments in 2009?
Offer a very short reply. 4.62e+11. What is the difference between the Expenses (in $) of Salary of employees in 2007 and the Expenses (in $) of Other expenses in 2009?
Provide a short and direct response. -1.22e+12. What is the difference between the Expenses (in $) in Custom duties in 2007 and the Expenses (in $) in Interest Payments in 2009?
Your answer should be very brief. -1.01e+1. What is the difference between the Expenses (in $) of Custom duties in 2007 and the Expenses (in $) of Other expenses in 2009?
Provide a short and direct response. -1.69e+12. What is the difference between the Expenses (in $) of Interest Payments in 2007 and the Expenses (in $) of Other expenses in 2009?
Provide a succinct answer. -1.68e+12. What is the difference between the Expenses (in $) in Salary of employees in 2007 and the Expenses (in $) in Custom duties in 2010?
Offer a terse response. 4.67e+11. What is the difference between the Expenses (in $) of Salary of employees in 2007 and the Expenses (in $) of Interest Payments in 2010?
Make the answer very short. 4.33e+11. What is the difference between the Expenses (in $) in Salary of employees in 2007 and the Expenses (in $) in Other expenses in 2010?
Provide a short and direct response. -1.32e+12. What is the difference between the Expenses (in $) in Custom duties in 2007 and the Expenses (in $) in Interest Payments in 2010?
Offer a very short reply. -3.87e+1. What is the difference between the Expenses (in $) of Custom duties in 2007 and the Expenses (in $) of Other expenses in 2010?
Offer a terse response. -1.79e+12. What is the difference between the Expenses (in $) in Interest Payments in 2007 and the Expenses (in $) in Other expenses in 2010?
Keep it short and to the point. -1.79e+12. What is the difference between the Expenses (in $) in Salary of employees in 2007 and the Expenses (in $) in Custom duties in 2011?
Your answer should be very brief. 4.60e+11. What is the difference between the Expenses (in $) of Salary of employees in 2007 and the Expenses (in $) of Interest Payments in 2011?
Give a very brief answer. 4.26e+11. What is the difference between the Expenses (in $) of Salary of employees in 2007 and the Expenses (in $) of Other expenses in 2011?
Provide a succinct answer. -1.64e+12. What is the difference between the Expenses (in $) of Custom duties in 2007 and the Expenses (in $) of Interest Payments in 2011?
Provide a short and direct response. -4.60e+1. What is the difference between the Expenses (in $) of Custom duties in 2007 and the Expenses (in $) of Other expenses in 2011?
Give a very brief answer. -2.11e+12. What is the difference between the Expenses (in $) in Interest Payments in 2007 and the Expenses (in $) in Other expenses in 2011?
Keep it short and to the point. -2.10e+12. What is the difference between the Expenses (in $) of Salary of employees in 2007 and the Expenses (in $) of Custom duties in 2012?
Offer a very short reply. 4.44e+11. What is the difference between the Expenses (in $) in Salary of employees in 2007 and the Expenses (in $) in Interest Payments in 2012?
Provide a short and direct response. 4.20e+11. What is the difference between the Expenses (in $) of Salary of employees in 2007 and the Expenses (in $) of Other expenses in 2012?
Your answer should be compact. -1.83e+12. What is the difference between the Expenses (in $) of Custom duties in 2007 and the Expenses (in $) of Interest Payments in 2012?
Make the answer very short. -5.23e+1. What is the difference between the Expenses (in $) of Custom duties in 2007 and the Expenses (in $) of Other expenses in 2012?
Provide a short and direct response. -2.30e+12. What is the difference between the Expenses (in $) in Interest Payments in 2007 and the Expenses (in $) in Other expenses in 2012?
Provide a short and direct response. -2.29e+12. What is the difference between the Expenses (in $) of Salary of employees in 2008 and the Expenses (in $) of Custom duties in 2009?
Provide a succinct answer. 5.08e+11. What is the difference between the Expenses (in $) of Salary of employees in 2008 and the Expenses (in $) of Interest Payments in 2009?
Offer a terse response. 4.87e+11. What is the difference between the Expenses (in $) of Salary of employees in 2008 and the Expenses (in $) of Other expenses in 2009?
Offer a very short reply. -1.19e+12. What is the difference between the Expenses (in $) in Custom duties in 2008 and the Expenses (in $) in Interest Payments in 2009?
Your answer should be very brief. -1.55e+09. What is the difference between the Expenses (in $) of Custom duties in 2008 and the Expenses (in $) of Other expenses in 2009?
Make the answer very short. -1.68e+12. What is the difference between the Expenses (in $) in Interest Payments in 2008 and the Expenses (in $) in Other expenses in 2009?
Provide a succinct answer. -1.69e+12. What is the difference between the Expenses (in $) of Salary of employees in 2008 and the Expenses (in $) of Custom duties in 2010?
Make the answer very short. 4.92e+11. What is the difference between the Expenses (in $) in Salary of employees in 2008 and the Expenses (in $) in Interest Payments in 2010?
Make the answer very short. 4.58e+11. What is the difference between the Expenses (in $) of Salary of employees in 2008 and the Expenses (in $) of Other expenses in 2010?
Make the answer very short. -1.30e+12. What is the difference between the Expenses (in $) of Custom duties in 2008 and the Expenses (in $) of Interest Payments in 2010?
Keep it short and to the point. -3.02e+1. What is the difference between the Expenses (in $) of Custom duties in 2008 and the Expenses (in $) of Other expenses in 2010?
Your answer should be very brief. -1.79e+12. What is the difference between the Expenses (in $) in Interest Payments in 2008 and the Expenses (in $) in Other expenses in 2010?
Your answer should be compact. -1.79e+12. What is the difference between the Expenses (in $) of Salary of employees in 2008 and the Expenses (in $) of Custom duties in 2011?
Provide a short and direct response. 4.85e+11. What is the difference between the Expenses (in $) of Salary of employees in 2008 and the Expenses (in $) of Interest Payments in 2011?
Offer a very short reply. 4.51e+11. What is the difference between the Expenses (in $) of Salary of employees in 2008 and the Expenses (in $) of Other expenses in 2011?
Your answer should be very brief. -1.61e+12. What is the difference between the Expenses (in $) of Custom duties in 2008 and the Expenses (in $) of Interest Payments in 2011?
Keep it short and to the point. -3.74e+1. What is the difference between the Expenses (in $) of Custom duties in 2008 and the Expenses (in $) of Other expenses in 2011?
Give a very brief answer. -2.10e+12. What is the difference between the Expenses (in $) of Interest Payments in 2008 and the Expenses (in $) of Other expenses in 2011?
Your answer should be compact. -2.11e+12. What is the difference between the Expenses (in $) in Salary of employees in 2008 and the Expenses (in $) in Custom duties in 2012?
Your response must be concise. 4.69e+11. What is the difference between the Expenses (in $) of Salary of employees in 2008 and the Expenses (in $) of Interest Payments in 2012?
Your answer should be very brief. 4.45e+11. What is the difference between the Expenses (in $) of Salary of employees in 2008 and the Expenses (in $) of Other expenses in 2012?
Provide a succinct answer. -1.80e+12. What is the difference between the Expenses (in $) in Custom duties in 2008 and the Expenses (in $) in Interest Payments in 2012?
Keep it short and to the point. -4.37e+1. What is the difference between the Expenses (in $) of Custom duties in 2008 and the Expenses (in $) of Other expenses in 2012?
Make the answer very short. -2.29e+12. What is the difference between the Expenses (in $) of Interest Payments in 2008 and the Expenses (in $) of Other expenses in 2012?
Provide a succinct answer. -2.30e+12. What is the difference between the Expenses (in $) of Salary of employees in 2009 and the Expenses (in $) of Custom duties in 2010?
Provide a succinct answer. 5.48e+11. What is the difference between the Expenses (in $) in Salary of employees in 2009 and the Expenses (in $) in Interest Payments in 2010?
Keep it short and to the point. 5.14e+11. What is the difference between the Expenses (in $) in Salary of employees in 2009 and the Expenses (in $) in Other expenses in 2010?
Offer a terse response. -1.24e+12. What is the difference between the Expenses (in $) in Custom duties in 2009 and the Expenses (in $) in Interest Payments in 2010?
Your answer should be very brief. -4.97e+1. What is the difference between the Expenses (in $) of Custom duties in 2009 and the Expenses (in $) of Other expenses in 2010?
Ensure brevity in your answer.  -1.81e+12. What is the difference between the Expenses (in $) in Interest Payments in 2009 and the Expenses (in $) in Other expenses in 2010?
Give a very brief answer. -1.78e+12. What is the difference between the Expenses (in $) of Salary of employees in 2009 and the Expenses (in $) of Custom duties in 2011?
Make the answer very short. 5.41e+11. What is the difference between the Expenses (in $) in Salary of employees in 2009 and the Expenses (in $) in Interest Payments in 2011?
Offer a very short reply. 5.07e+11. What is the difference between the Expenses (in $) in Salary of employees in 2009 and the Expenses (in $) in Other expenses in 2011?
Your answer should be compact. -1.55e+12. What is the difference between the Expenses (in $) in Custom duties in 2009 and the Expenses (in $) in Interest Payments in 2011?
Your answer should be very brief. -5.69e+1. What is the difference between the Expenses (in $) in Custom duties in 2009 and the Expenses (in $) in Other expenses in 2011?
Your response must be concise. -2.12e+12. What is the difference between the Expenses (in $) in Interest Payments in 2009 and the Expenses (in $) in Other expenses in 2011?
Make the answer very short. -2.10e+12. What is the difference between the Expenses (in $) of Salary of employees in 2009 and the Expenses (in $) of Custom duties in 2012?
Offer a terse response. 5.25e+11. What is the difference between the Expenses (in $) in Salary of employees in 2009 and the Expenses (in $) in Interest Payments in 2012?
Make the answer very short. 5.01e+11. What is the difference between the Expenses (in $) of Salary of employees in 2009 and the Expenses (in $) of Other expenses in 2012?
Your answer should be compact. -1.75e+12. What is the difference between the Expenses (in $) in Custom duties in 2009 and the Expenses (in $) in Interest Payments in 2012?
Provide a short and direct response. -6.32e+1. What is the difference between the Expenses (in $) in Custom duties in 2009 and the Expenses (in $) in Other expenses in 2012?
Offer a very short reply. -2.31e+12. What is the difference between the Expenses (in $) of Interest Payments in 2009 and the Expenses (in $) of Other expenses in 2012?
Your response must be concise. -2.29e+12. What is the difference between the Expenses (in $) of Salary of employees in 2010 and the Expenses (in $) of Custom duties in 2011?
Your answer should be compact. 6.56e+11. What is the difference between the Expenses (in $) in Salary of employees in 2010 and the Expenses (in $) in Interest Payments in 2011?
Your response must be concise. 6.21e+11. What is the difference between the Expenses (in $) of Salary of employees in 2010 and the Expenses (in $) of Other expenses in 2011?
Your response must be concise. -1.44e+12. What is the difference between the Expenses (in $) in Custom duties in 2010 and the Expenses (in $) in Interest Payments in 2011?
Ensure brevity in your answer.  -4.07e+1. What is the difference between the Expenses (in $) of Custom duties in 2010 and the Expenses (in $) of Other expenses in 2011?
Provide a short and direct response. -2.10e+12. What is the difference between the Expenses (in $) in Interest Payments in 2010 and the Expenses (in $) in Other expenses in 2011?
Your answer should be compact. -2.07e+12. What is the difference between the Expenses (in $) of Salary of employees in 2010 and the Expenses (in $) of Custom duties in 2012?
Your answer should be very brief. 6.39e+11. What is the difference between the Expenses (in $) of Salary of employees in 2010 and the Expenses (in $) of Interest Payments in 2012?
Keep it short and to the point. 6.15e+11. What is the difference between the Expenses (in $) of Salary of employees in 2010 and the Expenses (in $) of Other expenses in 2012?
Your answer should be very brief. -1.63e+12. What is the difference between the Expenses (in $) in Custom duties in 2010 and the Expenses (in $) in Interest Payments in 2012?
Make the answer very short. -4.70e+1. What is the difference between the Expenses (in $) in Custom duties in 2010 and the Expenses (in $) in Other expenses in 2012?
Give a very brief answer. -2.29e+12. What is the difference between the Expenses (in $) of Interest Payments in 2010 and the Expenses (in $) of Other expenses in 2012?
Keep it short and to the point. -2.26e+12. What is the difference between the Expenses (in $) in Salary of employees in 2011 and the Expenses (in $) in Custom duties in 2012?
Your response must be concise. 6.92e+11. What is the difference between the Expenses (in $) of Salary of employees in 2011 and the Expenses (in $) of Interest Payments in 2012?
Provide a short and direct response. 6.68e+11. What is the difference between the Expenses (in $) of Salary of employees in 2011 and the Expenses (in $) of Other expenses in 2012?
Your answer should be compact. -1.58e+12. What is the difference between the Expenses (in $) of Custom duties in 2011 and the Expenses (in $) of Interest Payments in 2012?
Make the answer very short. -4.06e+1. What is the difference between the Expenses (in $) of Custom duties in 2011 and the Expenses (in $) of Other expenses in 2012?
Your answer should be compact. -2.29e+12. What is the difference between the Expenses (in $) of Interest Payments in 2011 and the Expenses (in $) of Other expenses in 2012?
Provide a succinct answer. -2.25e+12. What is the average Expenses (in $) of Salary of employees per year?
Give a very brief answer. 6.11e+11. What is the average Expenses (in $) in Custom duties per year?
Your answer should be very brief. 9.68e+1. What is the average Expenses (in $) of Interest Payments per year?
Keep it short and to the point. 1.08e+11. What is the average Expenses (in $) of Other expenses per year?
Offer a very short reply. 1.66e+12. In the year 2004, what is the difference between the Expenses (in $) of Salary of employees and Expenses (in $) of Custom duties?
Give a very brief answer. 2.55e+11. In the year 2004, what is the difference between the Expenses (in $) in Salary of employees and Expenses (in $) in Interest Payments?
Provide a succinct answer. 2.73e+11. In the year 2004, what is the difference between the Expenses (in $) of Salary of employees and Expenses (in $) of Other expenses?
Provide a short and direct response. -7.19e+11. In the year 2004, what is the difference between the Expenses (in $) of Custom duties and Expenses (in $) of Interest Payments?
Give a very brief answer. 1.82e+1. In the year 2004, what is the difference between the Expenses (in $) of Custom duties and Expenses (in $) of Other expenses?
Give a very brief answer. -9.74e+11. In the year 2004, what is the difference between the Expenses (in $) of Interest Payments and Expenses (in $) of Other expenses?
Provide a succinct answer. -9.92e+11. In the year 2005, what is the difference between the Expenses (in $) in Salary of employees and Expenses (in $) in Custom duties?
Your answer should be compact. 2.96e+11. In the year 2005, what is the difference between the Expenses (in $) in Salary of employees and Expenses (in $) in Interest Payments?
Give a very brief answer. 3.12e+11. In the year 2005, what is the difference between the Expenses (in $) of Salary of employees and Expenses (in $) of Other expenses?
Make the answer very short. -7.63e+11. In the year 2005, what is the difference between the Expenses (in $) of Custom duties and Expenses (in $) of Interest Payments?
Your answer should be very brief. 1.66e+1. In the year 2005, what is the difference between the Expenses (in $) of Custom duties and Expenses (in $) of Other expenses?
Provide a succinct answer. -1.06e+12. In the year 2005, what is the difference between the Expenses (in $) in Interest Payments and Expenses (in $) in Other expenses?
Keep it short and to the point. -1.08e+12. In the year 2006, what is the difference between the Expenses (in $) in Salary of employees and Expenses (in $) in Custom duties?
Offer a terse response. 4.12e+11. In the year 2006, what is the difference between the Expenses (in $) in Salary of employees and Expenses (in $) in Interest Payments?
Your answer should be very brief. 3.93e+11. In the year 2006, what is the difference between the Expenses (in $) of Salary of employees and Expenses (in $) of Other expenses?
Ensure brevity in your answer.  -7.60e+11. In the year 2006, what is the difference between the Expenses (in $) in Custom duties and Expenses (in $) in Interest Payments?
Provide a short and direct response. -1.90e+1. In the year 2006, what is the difference between the Expenses (in $) in Custom duties and Expenses (in $) in Other expenses?
Your answer should be very brief. -1.17e+12. In the year 2006, what is the difference between the Expenses (in $) in Interest Payments and Expenses (in $) in Other expenses?
Your answer should be very brief. -1.15e+12. In the year 2007, what is the difference between the Expenses (in $) in Salary of employees and Expenses (in $) in Custom duties?
Offer a very short reply. 4.72e+11. In the year 2007, what is the difference between the Expenses (in $) in Salary of employees and Expenses (in $) in Interest Payments?
Your answer should be compact. 4.66e+11. In the year 2007, what is the difference between the Expenses (in $) in Salary of employees and Expenses (in $) in Other expenses?
Make the answer very short. -9.43e+11. In the year 2007, what is the difference between the Expenses (in $) of Custom duties and Expenses (in $) of Interest Payments?
Offer a very short reply. -5.91e+09. In the year 2007, what is the difference between the Expenses (in $) of Custom duties and Expenses (in $) of Other expenses?
Ensure brevity in your answer.  -1.41e+12. In the year 2007, what is the difference between the Expenses (in $) in Interest Payments and Expenses (in $) in Other expenses?
Offer a terse response. -1.41e+12. In the year 2008, what is the difference between the Expenses (in $) of Salary of employees and Expenses (in $) of Custom duties?
Keep it short and to the point. 4.88e+11. In the year 2008, what is the difference between the Expenses (in $) in Salary of employees and Expenses (in $) in Interest Payments?
Offer a very short reply. 4.95e+11. In the year 2008, what is the difference between the Expenses (in $) of Salary of employees and Expenses (in $) of Other expenses?
Your answer should be very brief. -1.07e+12. In the year 2008, what is the difference between the Expenses (in $) of Custom duties and Expenses (in $) of Interest Payments?
Ensure brevity in your answer.  6.20e+09. In the year 2008, what is the difference between the Expenses (in $) of Custom duties and Expenses (in $) of Other expenses?
Your response must be concise. -1.56e+12. In the year 2008, what is the difference between the Expenses (in $) in Interest Payments and Expenses (in $) in Other expenses?
Provide a succinct answer. -1.57e+12. In the year 2009, what is the difference between the Expenses (in $) in Salary of employees and Expenses (in $) in Custom duties?
Make the answer very short. 5.64e+11. In the year 2009, what is the difference between the Expenses (in $) of Salary of employees and Expenses (in $) of Interest Payments?
Offer a very short reply. 5.43e+11. In the year 2009, what is the difference between the Expenses (in $) in Salary of employees and Expenses (in $) in Other expenses?
Offer a terse response. -1.14e+12. In the year 2009, what is the difference between the Expenses (in $) of Custom duties and Expenses (in $) of Interest Payments?
Your response must be concise. -2.11e+1. In the year 2009, what is the difference between the Expenses (in $) in Custom duties and Expenses (in $) in Other expenses?
Offer a very short reply. -1.70e+12. In the year 2009, what is the difference between the Expenses (in $) in Interest Payments and Expenses (in $) in Other expenses?
Provide a succinct answer. -1.68e+12. In the year 2010, what is the difference between the Expenses (in $) in Salary of employees and Expenses (in $) in Custom duties?
Make the answer very short. 6.62e+11. In the year 2010, what is the difference between the Expenses (in $) in Salary of employees and Expenses (in $) in Interest Payments?
Provide a short and direct response. 6.29e+11. In the year 2010, what is the difference between the Expenses (in $) in Salary of employees and Expenses (in $) in Other expenses?
Offer a very short reply. -1.13e+12. In the year 2010, what is the difference between the Expenses (in $) of Custom duties and Expenses (in $) of Interest Payments?
Keep it short and to the point. -3.35e+1. In the year 2010, what is the difference between the Expenses (in $) in Custom duties and Expenses (in $) in Other expenses?
Your answer should be very brief. -1.79e+12. In the year 2010, what is the difference between the Expenses (in $) in Interest Payments and Expenses (in $) in Other expenses?
Offer a very short reply. -1.76e+12. In the year 2011, what is the difference between the Expenses (in $) of Salary of employees and Expenses (in $) of Custom duties?
Give a very brief answer. 7.09e+11. In the year 2011, what is the difference between the Expenses (in $) of Salary of employees and Expenses (in $) of Interest Payments?
Your answer should be compact. 6.74e+11. In the year 2011, what is the difference between the Expenses (in $) of Salary of employees and Expenses (in $) of Other expenses?
Your answer should be compact. -1.39e+12. In the year 2011, what is the difference between the Expenses (in $) of Custom duties and Expenses (in $) of Interest Payments?
Your answer should be very brief. -3.43e+1. In the year 2011, what is the difference between the Expenses (in $) in Custom duties and Expenses (in $) in Other expenses?
Give a very brief answer. -2.10e+12. In the year 2011, what is the difference between the Expenses (in $) in Interest Payments and Expenses (in $) in Other expenses?
Your response must be concise. -2.06e+12. In the year 2012, what is the difference between the Expenses (in $) in Salary of employees and Expenses (in $) in Custom duties?
Your response must be concise. 7.71e+11. In the year 2012, what is the difference between the Expenses (in $) of Salary of employees and Expenses (in $) of Interest Payments?
Give a very brief answer. 7.47e+11. In the year 2012, what is the difference between the Expenses (in $) of Salary of employees and Expenses (in $) of Other expenses?
Ensure brevity in your answer.  -1.50e+12. In the year 2012, what is the difference between the Expenses (in $) in Custom duties and Expenses (in $) in Interest Payments?
Your answer should be compact. -2.43e+1. In the year 2012, what is the difference between the Expenses (in $) in Custom duties and Expenses (in $) in Other expenses?
Provide a short and direct response. -2.27e+12. In the year 2012, what is the difference between the Expenses (in $) in Interest Payments and Expenses (in $) in Other expenses?
Keep it short and to the point. -2.25e+12. What is the ratio of the Expenses (in $) of Salary of employees in 2004 to that in 2005?
Make the answer very short. 0.89. What is the ratio of the Expenses (in $) in Custom duties in 2004 to that in 2005?
Offer a very short reply. 0.96. What is the ratio of the Expenses (in $) of Interest Payments in 2004 to that in 2005?
Offer a very short reply. 0.94. What is the ratio of the Expenses (in $) of Other expenses in 2004 to that in 2005?
Make the answer very short. 0.92. What is the ratio of the Expenses (in $) of Salary of employees in 2004 to that in 2006?
Ensure brevity in your answer.  0.71. What is the ratio of the Expenses (in $) in Custom duties in 2004 to that in 2006?
Offer a very short reply. 1.1. What is the ratio of the Expenses (in $) in Interest Payments in 2004 to that in 2006?
Your answer should be very brief. 0.75. What is the ratio of the Expenses (in $) of Other expenses in 2004 to that in 2006?
Your answer should be very brief. 0.85. What is the ratio of the Expenses (in $) in Salary of employees in 2004 to that in 2007?
Your answer should be very brief. 0.64. What is the ratio of the Expenses (in $) of Custom duties in 2004 to that in 2007?
Your response must be concise. 1.18. What is the ratio of the Expenses (in $) in Interest Payments in 2004 to that in 2007?
Make the answer very short. 0.91. What is the ratio of the Expenses (in $) of Other expenses in 2004 to that in 2007?
Your answer should be compact. 0.72. What is the ratio of the Expenses (in $) of Salary of employees in 2004 to that in 2008?
Make the answer very short. 0.61. What is the ratio of the Expenses (in $) in Custom duties in 2004 to that in 2008?
Provide a short and direct response. 1.08. What is the ratio of the Expenses (in $) of Interest Payments in 2004 to that in 2008?
Your answer should be very brief. 0.95. What is the ratio of the Expenses (in $) in Other expenses in 2004 to that in 2008?
Provide a short and direct response. 0.65. What is the ratio of the Expenses (in $) in Salary of employees in 2004 to that in 2009?
Ensure brevity in your answer.  0.56. What is the ratio of the Expenses (in $) in Custom duties in 2004 to that in 2009?
Keep it short and to the point. 1.35. What is the ratio of the Expenses (in $) of Interest Payments in 2004 to that in 2009?
Provide a succinct answer. 0.87. What is the ratio of the Expenses (in $) in Other expenses in 2004 to that in 2009?
Your response must be concise. 0.61. What is the ratio of the Expenses (in $) in Salary of employees in 2004 to that in 2010?
Provide a succinct answer. 0.47. What is the ratio of the Expenses (in $) of Custom duties in 2004 to that in 2010?
Keep it short and to the point. 1.11. What is the ratio of the Expenses (in $) in Interest Payments in 2004 to that in 2010?
Make the answer very short. 0.67. What is the ratio of the Expenses (in $) of Other expenses in 2004 to that in 2010?
Give a very brief answer. 0.57. What is the ratio of the Expenses (in $) in Salary of employees in 2004 to that in 2011?
Make the answer very short. 0.44. What is the ratio of the Expenses (in $) in Custom duties in 2004 to that in 2011?
Make the answer very short. 1.04. What is the ratio of the Expenses (in $) in Interest Payments in 2004 to that in 2011?
Give a very brief answer. 0.64. What is the ratio of the Expenses (in $) in Other expenses in 2004 to that in 2011?
Your answer should be very brief. 0.49. What is the ratio of the Expenses (in $) in Salary of employees in 2004 to that in 2012?
Offer a very short reply. 0.4. What is the ratio of the Expenses (in $) in Custom duties in 2004 to that in 2012?
Keep it short and to the point. 0.9. What is the ratio of the Expenses (in $) in Interest Payments in 2004 to that in 2012?
Provide a short and direct response. 0.61. What is the ratio of the Expenses (in $) of Other expenses in 2004 to that in 2012?
Offer a very short reply. 0.45. What is the ratio of the Expenses (in $) of Salary of employees in 2005 to that in 2006?
Offer a very short reply. 0.8. What is the ratio of the Expenses (in $) in Custom duties in 2005 to that in 2006?
Make the answer very short. 1.15. What is the ratio of the Expenses (in $) of Interest Payments in 2005 to that in 2006?
Provide a short and direct response. 0.81. What is the ratio of the Expenses (in $) in Other expenses in 2005 to that in 2006?
Your answer should be compact. 0.92. What is the ratio of the Expenses (in $) in Salary of employees in 2005 to that in 2007?
Your answer should be compact. 0.72. What is the ratio of the Expenses (in $) in Custom duties in 2005 to that in 2007?
Offer a very short reply. 1.23. What is the ratio of the Expenses (in $) of Interest Payments in 2005 to that in 2007?
Make the answer very short. 0.97. What is the ratio of the Expenses (in $) in Other expenses in 2005 to that in 2007?
Provide a succinct answer. 0.78. What is the ratio of the Expenses (in $) in Salary of employees in 2005 to that in 2008?
Make the answer very short. 0.69. What is the ratio of the Expenses (in $) in Custom duties in 2005 to that in 2008?
Your answer should be very brief. 1.12. What is the ratio of the Expenses (in $) in Interest Payments in 2005 to that in 2008?
Offer a very short reply. 1.01. What is the ratio of the Expenses (in $) of Other expenses in 2005 to that in 2008?
Your answer should be compact. 0.7. What is the ratio of the Expenses (in $) in Salary of employees in 2005 to that in 2009?
Provide a short and direct response. 0.63. What is the ratio of the Expenses (in $) in Custom duties in 2005 to that in 2009?
Your response must be concise. 1.4. What is the ratio of the Expenses (in $) in Interest Payments in 2005 to that in 2009?
Your response must be concise. 0.93. What is the ratio of the Expenses (in $) of Other expenses in 2005 to that in 2009?
Provide a short and direct response. 0.66. What is the ratio of the Expenses (in $) of Salary of employees in 2005 to that in 2010?
Make the answer very short. 0.53. What is the ratio of the Expenses (in $) in Custom duties in 2005 to that in 2010?
Your response must be concise. 1.16. What is the ratio of the Expenses (in $) in Interest Payments in 2005 to that in 2010?
Offer a very short reply. 0.72. What is the ratio of the Expenses (in $) of Other expenses in 2005 to that in 2010?
Your answer should be very brief. 0.62. What is the ratio of the Expenses (in $) of Salary of employees in 2005 to that in 2011?
Your response must be concise. 0.5. What is the ratio of the Expenses (in $) of Custom duties in 2005 to that in 2011?
Offer a terse response. 1.08. What is the ratio of the Expenses (in $) in Interest Payments in 2005 to that in 2011?
Make the answer very short. 0.68. What is the ratio of the Expenses (in $) in Other expenses in 2005 to that in 2011?
Offer a very short reply. 0.53. What is the ratio of the Expenses (in $) in Salary of employees in 2005 to that in 2012?
Your answer should be very brief. 0.45. What is the ratio of the Expenses (in $) in Custom duties in 2005 to that in 2012?
Provide a succinct answer. 0.93. What is the ratio of the Expenses (in $) of Interest Payments in 2005 to that in 2012?
Offer a terse response. 0.65. What is the ratio of the Expenses (in $) in Other expenses in 2005 to that in 2012?
Offer a very short reply. 0.49. What is the ratio of the Expenses (in $) of Salary of employees in 2006 to that in 2007?
Make the answer very short. 0.9. What is the ratio of the Expenses (in $) of Custom duties in 2006 to that in 2007?
Keep it short and to the point. 1.07. What is the ratio of the Expenses (in $) in Interest Payments in 2006 to that in 2007?
Ensure brevity in your answer.  1.21. What is the ratio of the Expenses (in $) of Other expenses in 2006 to that in 2007?
Your answer should be compact. 0.84. What is the ratio of the Expenses (in $) of Salary of employees in 2006 to that in 2008?
Ensure brevity in your answer.  0.87. What is the ratio of the Expenses (in $) of Custom duties in 2006 to that in 2008?
Provide a succinct answer. 0.98. What is the ratio of the Expenses (in $) in Interest Payments in 2006 to that in 2008?
Keep it short and to the point. 1.26. What is the ratio of the Expenses (in $) in Other expenses in 2006 to that in 2008?
Provide a short and direct response. 0.76. What is the ratio of the Expenses (in $) of Salary of employees in 2006 to that in 2009?
Ensure brevity in your answer.  0.79. What is the ratio of the Expenses (in $) of Custom duties in 2006 to that in 2009?
Provide a succinct answer. 1.23. What is the ratio of the Expenses (in $) of Interest Payments in 2006 to that in 2009?
Your answer should be compact. 1.16. What is the ratio of the Expenses (in $) in Other expenses in 2006 to that in 2009?
Offer a very short reply. 0.71. What is the ratio of the Expenses (in $) of Salary of employees in 2006 to that in 2010?
Provide a succinct answer. 0.67. What is the ratio of the Expenses (in $) of Custom duties in 2006 to that in 2010?
Your answer should be compact. 1.01. What is the ratio of the Expenses (in $) in Interest Payments in 2006 to that in 2010?
Provide a succinct answer. 0.89. What is the ratio of the Expenses (in $) of Other expenses in 2006 to that in 2010?
Your answer should be very brief. 0.67. What is the ratio of the Expenses (in $) in Salary of employees in 2006 to that in 2011?
Provide a short and direct response. 0.63. What is the ratio of the Expenses (in $) in Custom duties in 2006 to that in 2011?
Give a very brief answer. 0.95. What is the ratio of the Expenses (in $) of Interest Payments in 2006 to that in 2011?
Offer a very short reply. 0.85. What is the ratio of the Expenses (in $) of Other expenses in 2006 to that in 2011?
Ensure brevity in your answer.  0.58. What is the ratio of the Expenses (in $) in Salary of employees in 2006 to that in 2012?
Provide a succinct answer. 0.57. What is the ratio of the Expenses (in $) of Custom duties in 2006 to that in 2012?
Provide a short and direct response. 0.81. What is the ratio of the Expenses (in $) of Interest Payments in 2006 to that in 2012?
Keep it short and to the point. 0.81. What is the ratio of the Expenses (in $) of Other expenses in 2006 to that in 2012?
Provide a succinct answer. 0.53. What is the ratio of the Expenses (in $) in Salary of employees in 2007 to that in 2008?
Offer a very short reply. 0.96. What is the ratio of the Expenses (in $) in Custom duties in 2007 to that in 2008?
Provide a succinct answer. 0.91. What is the ratio of the Expenses (in $) in Interest Payments in 2007 to that in 2008?
Provide a succinct answer. 1.04. What is the ratio of the Expenses (in $) of Other expenses in 2007 to that in 2008?
Keep it short and to the point. 0.91. What is the ratio of the Expenses (in $) of Salary of employees in 2007 to that in 2009?
Provide a short and direct response. 0.87. What is the ratio of the Expenses (in $) of Custom duties in 2007 to that in 2009?
Your answer should be compact. 1.14. What is the ratio of the Expenses (in $) of Interest Payments in 2007 to that in 2009?
Offer a terse response. 0.96. What is the ratio of the Expenses (in $) of Other expenses in 2007 to that in 2009?
Provide a short and direct response. 0.84. What is the ratio of the Expenses (in $) of Salary of employees in 2007 to that in 2010?
Your answer should be very brief. 0.74. What is the ratio of the Expenses (in $) of Custom duties in 2007 to that in 2010?
Provide a short and direct response. 0.94. What is the ratio of the Expenses (in $) in Interest Payments in 2007 to that in 2010?
Make the answer very short. 0.74. What is the ratio of the Expenses (in $) of Other expenses in 2007 to that in 2010?
Offer a terse response. 0.8. What is the ratio of the Expenses (in $) of Salary of employees in 2007 to that in 2011?
Ensure brevity in your answer.  0.69. What is the ratio of the Expenses (in $) of Custom duties in 2007 to that in 2011?
Offer a terse response. 0.88. What is the ratio of the Expenses (in $) in Interest Payments in 2007 to that in 2011?
Make the answer very short. 0.7. What is the ratio of the Expenses (in $) in Other expenses in 2007 to that in 2011?
Offer a very short reply. 0.68. What is the ratio of the Expenses (in $) in Salary of employees in 2007 to that in 2012?
Ensure brevity in your answer.  0.63. What is the ratio of the Expenses (in $) of Custom duties in 2007 to that in 2012?
Make the answer very short. 0.76. What is the ratio of the Expenses (in $) in Interest Payments in 2007 to that in 2012?
Ensure brevity in your answer.  0.67. What is the ratio of the Expenses (in $) in Other expenses in 2007 to that in 2012?
Your answer should be compact. 0.63. What is the ratio of the Expenses (in $) in Salary of employees in 2008 to that in 2009?
Make the answer very short. 0.91. What is the ratio of the Expenses (in $) in Custom duties in 2008 to that in 2009?
Make the answer very short. 1.26. What is the ratio of the Expenses (in $) in Interest Payments in 2008 to that in 2009?
Offer a terse response. 0.92. What is the ratio of the Expenses (in $) in Other expenses in 2008 to that in 2009?
Make the answer very short. 0.93. What is the ratio of the Expenses (in $) in Salary of employees in 2008 to that in 2010?
Provide a short and direct response. 0.77. What is the ratio of the Expenses (in $) of Custom duties in 2008 to that in 2010?
Your response must be concise. 1.04. What is the ratio of the Expenses (in $) in Interest Payments in 2008 to that in 2010?
Your response must be concise. 0.71. What is the ratio of the Expenses (in $) of Other expenses in 2008 to that in 2010?
Your answer should be compact. 0.88. What is the ratio of the Expenses (in $) in Salary of employees in 2008 to that in 2011?
Ensure brevity in your answer.  0.72. What is the ratio of the Expenses (in $) in Custom duties in 2008 to that in 2011?
Give a very brief answer. 0.97. What is the ratio of the Expenses (in $) of Interest Payments in 2008 to that in 2011?
Give a very brief answer. 0.67. What is the ratio of the Expenses (in $) of Other expenses in 2008 to that in 2011?
Your answer should be very brief. 0.75. What is the ratio of the Expenses (in $) of Salary of employees in 2008 to that in 2012?
Give a very brief answer. 0.66. What is the ratio of the Expenses (in $) of Custom duties in 2008 to that in 2012?
Your answer should be compact. 0.83. What is the ratio of the Expenses (in $) in Interest Payments in 2008 to that in 2012?
Give a very brief answer. 0.64. What is the ratio of the Expenses (in $) of Other expenses in 2008 to that in 2012?
Your response must be concise. 0.69. What is the ratio of the Expenses (in $) in Salary of employees in 2009 to that in 2010?
Give a very brief answer. 0.85. What is the ratio of the Expenses (in $) of Custom duties in 2009 to that in 2010?
Give a very brief answer. 0.83. What is the ratio of the Expenses (in $) in Interest Payments in 2009 to that in 2010?
Your response must be concise. 0.77. What is the ratio of the Expenses (in $) in Other expenses in 2009 to that in 2010?
Offer a terse response. 0.94. What is the ratio of the Expenses (in $) of Salary of employees in 2009 to that in 2011?
Keep it short and to the point. 0.79. What is the ratio of the Expenses (in $) in Custom duties in 2009 to that in 2011?
Ensure brevity in your answer.  0.77. What is the ratio of the Expenses (in $) of Interest Payments in 2009 to that in 2011?
Offer a very short reply. 0.73. What is the ratio of the Expenses (in $) of Other expenses in 2009 to that in 2011?
Offer a terse response. 0.81. What is the ratio of the Expenses (in $) in Salary of employees in 2009 to that in 2012?
Make the answer very short. 0.72. What is the ratio of the Expenses (in $) of Custom duties in 2009 to that in 2012?
Give a very brief answer. 0.66. What is the ratio of the Expenses (in $) in Interest Payments in 2009 to that in 2012?
Give a very brief answer. 0.7. What is the ratio of the Expenses (in $) in Other expenses in 2009 to that in 2012?
Keep it short and to the point. 0.75. What is the ratio of the Expenses (in $) of Salary of employees in 2010 to that in 2011?
Give a very brief answer. 0.93. What is the ratio of the Expenses (in $) in Custom duties in 2010 to that in 2011?
Offer a terse response. 0.94. What is the ratio of the Expenses (in $) of Interest Payments in 2010 to that in 2011?
Your response must be concise. 0.95. What is the ratio of the Expenses (in $) of Salary of employees in 2010 to that in 2012?
Offer a very short reply. 0.85. What is the ratio of the Expenses (in $) of Custom duties in 2010 to that in 2012?
Ensure brevity in your answer.  0.8. What is the ratio of the Expenses (in $) in Interest Payments in 2010 to that in 2012?
Give a very brief answer. 0.9. What is the ratio of the Expenses (in $) of Other expenses in 2010 to that in 2012?
Your answer should be compact. 0.79. What is the ratio of the Expenses (in $) of Salary of employees in 2011 to that in 2012?
Provide a short and direct response. 0.91. What is the ratio of the Expenses (in $) of Custom duties in 2011 to that in 2012?
Offer a very short reply. 0.86. What is the ratio of the Expenses (in $) in Interest Payments in 2011 to that in 2012?
Your answer should be compact. 0.95. What is the ratio of the Expenses (in $) of Other expenses in 2011 to that in 2012?
Ensure brevity in your answer.  0.92. What is the difference between the highest and the second highest Expenses (in $) of Salary of employees?
Offer a very short reply. 7.91e+1. What is the difference between the highest and the second highest Expenses (in $) in Custom duties?
Your answer should be very brief. 8.00e+09. What is the difference between the highest and the second highest Expenses (in $) of Interest Payments?
Your response must be concise. 6.33e+09. What is the difference between the highest and the second highest Expenses (in $) of Other expenses?
Your answer should be compact. 1.91e+11. What is the difference between the highest and the lowest Expenses (in $) of Salary of employees?
Your answer should be very brief. 5.29e+11. What is the difference between the highest and the lowest Expenses (in $) of Custom duties?
Make the answer very short. 3.89e+1. What is the difference between the highest and the lowest Expenses (in $) of Interest Payments?
Your answer should be compact. 5.46e+1. What is the difference between the highest and the lowest Expenses (in $) of Other expenses?
Provide a short and direct response. 1.31e+12. 